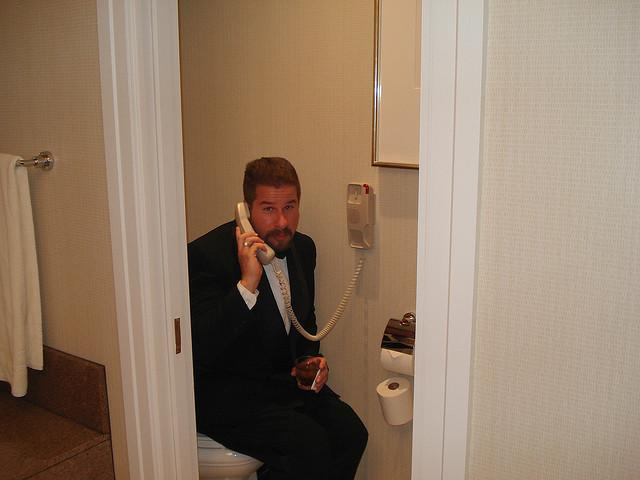What is he doing? talking 